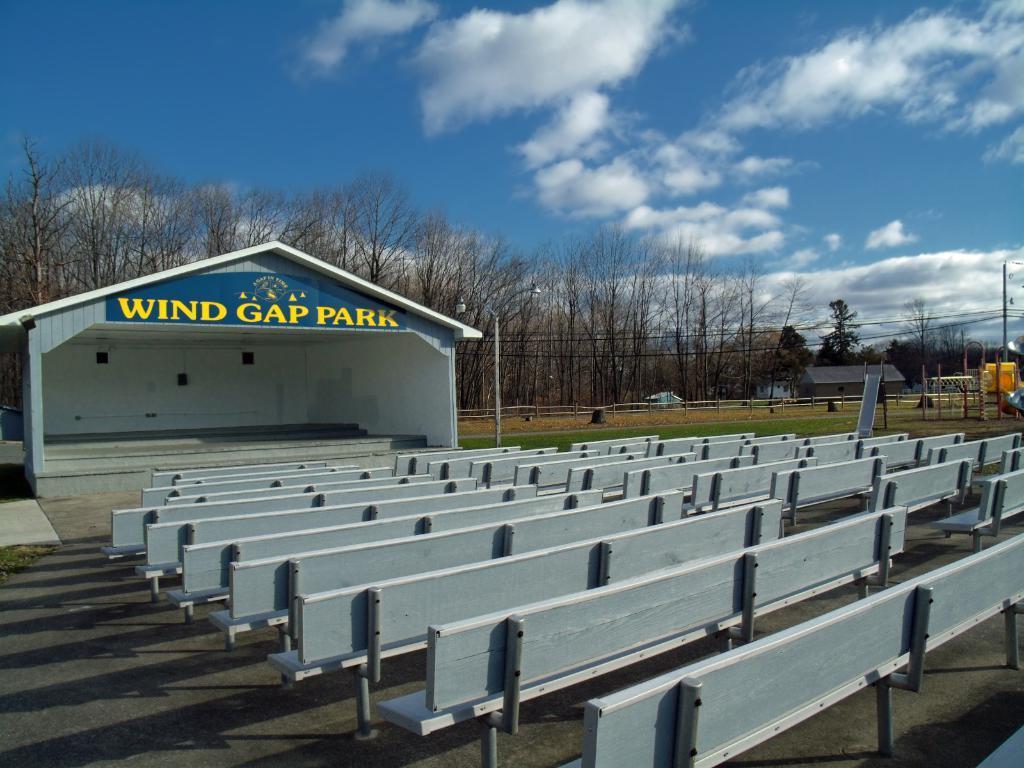In one or two sentences, can you explain what this image depicts? In this image in front there are benches. In the center of the image there is a house. There is a wooden fence. On the right side of the image there are few objects. In the background of the image there are trees, lights, current poles and sky. At the bottom of the image there is a road. 